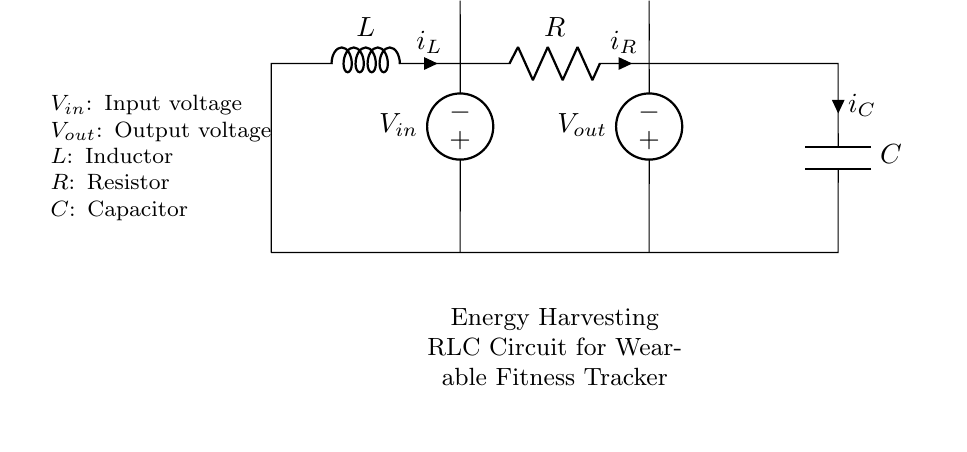What does the circuit consist of? The circuit consists of an inductor, resistor, and capacitor arranged in a loop along with input and output voltage sources.
Answer: Inductor, resistor, capacitor What is the role of the inductor in this circuit? The inductor stores energy in the form of a magnetic field when current flows through it and helps stabilize the circuit's response to changes in current.
Answer: Energy storage What is the voltage at the input source? The input voltage source is labeled as V_in, which represents the voltage supplied to the circuit.
Answer: V_in How many components are in the circuit? There are four components in total: one inductor, one resistor, one capacitor, and two voltage sources.
Answer: Four What is the current direction through the capacitor? The current through the capacitor is marked with an arrow pointing towards the capacitor, indicating the conventional current flows into the capacitor.
Answer: From left to right What happens when the resistor value increases? Increasing the resistor value will reduce the overall current in the circuit according to Ohm's law, affecting the energy transfer across the inductor and capacitor.
Answer: Current decreases What type of circuit is shown? The circuit is identified as a resonant or RLC circuit, as it includes a resistor, inductor, and capacitor.
Answer: RLC circuit 